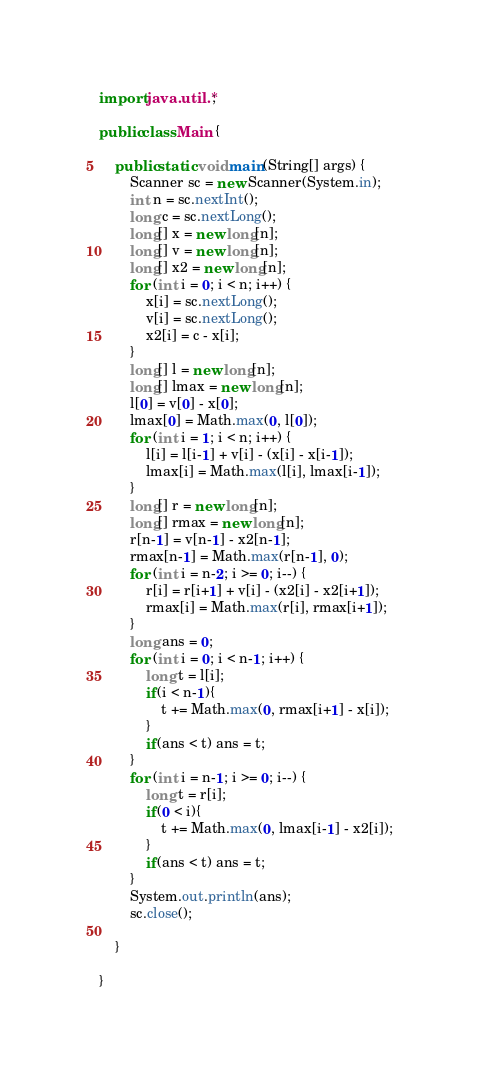<code> <loc_0><loc_0><loc_500><loc_500><_Java_>import java.util.*;

public class Main {

    public static void main(String[] args) {
        Scanner sc = new Scanner(System.in);
        int n = sc.nextInt();
        long c = sc.nextLong();
        long[] x = new long[n];
        long[] v = new long[n];
        long[] x2 = new long[n];
        for (int i = 0; i < n; i++) {
            x[i] = sc.nextLong();
            v[i] = sc.nextLong();
            x2[i] = c - x[i];
        }
        long[] l = new long[n];
        long[] lmax = new long[n];
        l[0] = v[0] - x[0];
        lmax[0] = Math.max(0, l[0]);
        for (int i = 1; i < n; i++) {
            l[i] = l[i-1] + v[i] - (x[i] - x[i-1]);
            lmax[i] = Math.max(l[i], lmax[i-1]);
        }
        long[] r = new long[n];
        long[] rmax = new long[n];
        r[n-1] = v[n-1] - x2[n-1];
        rmax[n-1] = Math.max(r[n-1], 0);
        for (int i = n-2; i >= 0; i--) {
            r[i] = r[i+1] + v[i] - (x2[i] - x2[i+1]);
            rmax[i] = Math.max(r[i], rmax[i+1]);
        }
        long ans = 0;
        for (int i = 0; i < n-1; i++) {
            long t = l[i];
            if(i < n-1){
                t += Math.max(0, rmax[i+1] - x[i]);
            }
            if(ans < t) ans = t;
        }
        for (int i = n-1; i >= 0; i--) {
            long t = r[i];
            if(0 < i){
                t += Math.max(0, lmax[i-1] - x2[i]);
            }
            if(ans < t) ans = t;
        }
        System.out.println(ans);
        sc.close();

    }

}
</code> 